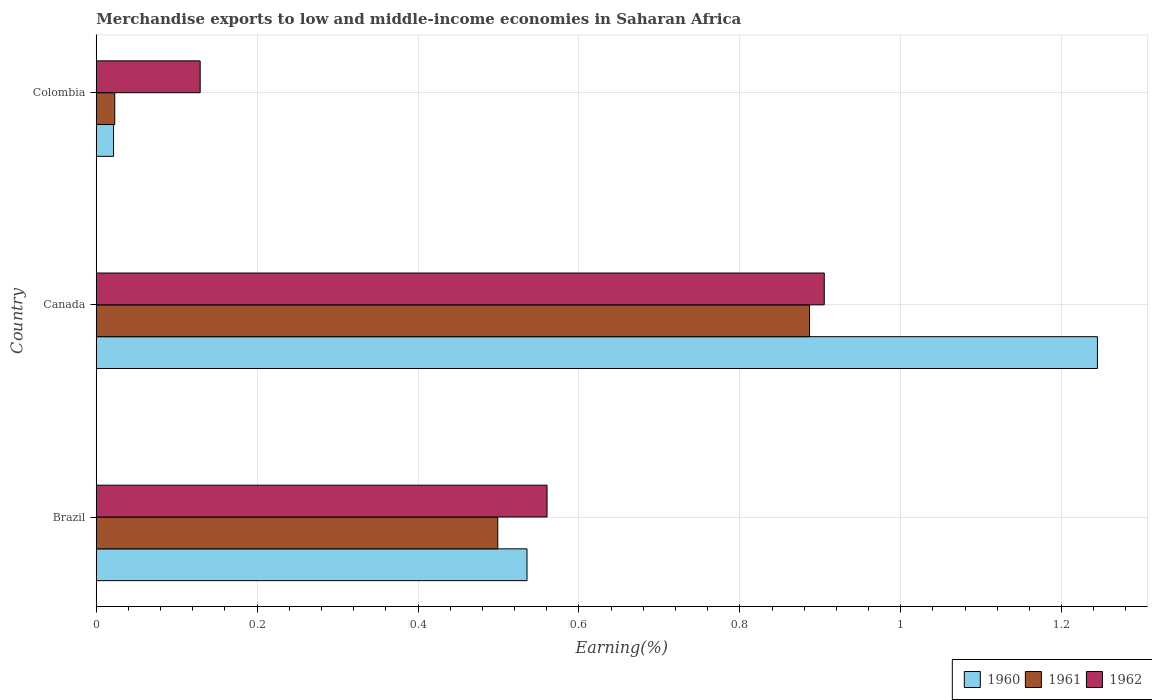How many different coloured bars are there?
Offer a very short reply. 3. Are the number of bars per tick equal to the number of legend labels?
Offer a very short reply. Yes. How many bars are there on the 3rd tick from the top?
Your answer should be compact. 3. What is the label of the 1st group of bars from the top?
Give a very brief answer. Colombia. In how many cases, is the number of bars for a given country not equal to the number of legend labels?
Your response must be concise. 0. What is the percentage of amount earned from merchandise exports in 1960 in Canada?
Ensure brevity in your answer.  1.24. Across all countries, what is the maximum percentage of amount earned from merchandise exports in 1962?
Provide a succinct answer. 0.9. Across all countries, what is the minimum percentage of amount earned from merchandise exports in 1961?
Offer a very short reply. 0.02. In which country was the percentage of amount earned from merchandise exports in 1961 maximum?
Provide a short and direct response. Canada. What is the total percentage of amount earned from merchandise exports in 1961 in the graph?
Provide a succinct answer. 1.41. What is the difference between the percentage of amount earned from merchandise exports in 1961 in Brazil and that in Colombia?
Your answer should be very brief. 0.48. What is the difference between the percentage of amount earned from merchandise exports in 1960 in Canada and the percentage of amount earned from merchandise exports in 1961 in Colombia?
Offer a terse response. 1.22. What is the average percentage of amount earned from merchandise exports in 1960 per country?
Offer a terse response. 0.6. What is the difference between the percentage of amount earned from merchandise exports in 1962 and percentage of amount earned from merchandise exports in 1960 in Colombia?
Make the answer very short. 0.11. What is the ratio of the percentage of amount earned from merchandise exports in 1961 in Brazil to that in Colombia?
Offer a terse response. 21.72. Is the difference between the percentage of amount earned from merchandise exports in 1962 in Canada and Colombia greater than the difference between the percentage of amount earned from merchandise exports in 1960 in Canada and Colombia?
Offer a very short reply. No. What is the difference between the highest and the second highest percentage of amount earned from merchandise exports in 1961?
Your response must be concise. 0.39. What is the difference between the highest and the lowest percentage of amount earned from merchandise exports in 1962?
Give a very brief answer. 0.78. How many bars are there?
Provide a short and direct response. 9. How many countries are there in the graph?
Your answer should be very brief. 3. What is the difference between two consecutive major ticks on the X-axis?
Provide a succinct answer. 0.2. Are the values on the major ticks of X-axis written in scientific E-notation?
Offer a terse response. No. Does the graph contain any zero values?
Ensure brevity in your answer.  No. Does the graph contain grids?
Your answer should be compact. Yes. Where does the legend appear in the graph?
Your answer should be very brief. Bottom right. How are the legend labels stacked?
Offer a terse response. Horizontal. What is the title of the graph?
Offer a very short reply. Merchandise exports to low and middle-income economies in Saharan Africa. Does "2011" appear as one of the legend labels in the graph?
Your answer should be very brief. No. What is the label or title of the X-axis?
Your answer should be compact. Earning(%). What is the label or title of the Y-axis?
Keep it short and to the point. Country. What is the Earning(%) in 1960 in Brazil?
Make the answer very short. 0.54. What is the Earning(%) in 1961 in Brazil?
Your answer should be compact. 0.5. What is the Earning(%) of 1962 in Brazil?
Offer a terse response. 0.56. What is the Earning(%) in 1960 in Canada?
Provide a short and direct response. 1.24. What is the Earning(%) in 1961 in Canada?
Your answer should be very brief. 0.89. What is the Earning(%) of 1962 in Canada?
Provide a succinct answer. 0.9. What is the Earning(%) in 1960 in Colombia?
Your answer should be compact. 0.02. What is the Earning(%) of 1961 in Colombia?
Make the answer very short. 0.02. What is the Earning(%) in 1962 in Colombia?
Give a very brief answer. 0.13. Across all countries, what is the maximum Earning(%) in 1960?
Keep it short and to the point. 1.24. Across all countries, what is the maximum Earning(%) in 1961?
Your response must be concise. 0.89. Across all countries, what is the maximum Earning(%) of 1962?
Offer a very short reply. 0.9. Across all countries, what is the minimum Earning(%) in 1960?
Keep it short and to the point. 0.02. Across all countries, what is the minimum Earning(%) in 1961?
Ensure brevity in your answer.  0.02. Across all countries, what is the minimum Earning(%) of 1962?
Keep it short and to the point. 0.13. What is the total Earning(%) of 1960 in the graph?
Make the answer very short. 1.8. What is the total Earning(%) of 1961 in the graph?
Offer a terse response. 1.41. What is the total Earning(%) in 1962 in the graph?
Your answer should be very brief. 1.59. What is the difference between the Earning(%) in 1960 in Brazil and that in Canada?
Provide a short and direct response. -0.71. What is the difference between the Earning(%) of 1961 in Brazil and that in Canada?
Make the answer very short. -0.39. What is the difference between the Earning(%) of 1962 in Brazil and that in Canada?
Your answer should be compact. -0.34. What is the difference between the Earning(%) of 1960 in Brazil and that in Colombia?
Your answer should be very brief. 0.51. What is the difference between the Earning(%) of 1961 in Brazil and that in Colombia?
Make the answer very short. 0.48. What is the difference between the Earning(%) of 1962 in Brazil and that in Colombia?
Make the answer very short. 0.43. What is the difference between the Earning(%) of 1960 in Canada and that in Colombia?
Provide a succinct answer. 1.22. What is the difference between the Earning(%) in 1961 in Canada and that in Colombia?
Your response must be concise. 0.86. What is the difference between the Earning(%) in 1962 in Canada and that in Colombia?
Make the answer very short. 0.78. What is the difference between the Earning(%) in 1960 in Brazil and the Earning(%) in 1961 in Canada?
Offer a terse response. -0.35. What is the difference between the Earning(%) in 1960 in Brazil and the Earning(%) in 1962 in Canada?
Offer a very short reply. -0.37. What is the difference between the Earning(%) of 1961 in Brazil and the Earning(%) of 1962 in Canada?
Keep it short and to the point. -0.41. What is the difference between the Earning(%) of 1960 in Brazil and the Earning(%) of 1961 in Colombia?
Keep it short and to the point. 0.51. What is the difference between the Earning(%) in 1960 in Brazil and the Earning(%) in 1962 in Colombia?
Make the answer very short. 0.41. What is the difference between the Earning(%) in 1961 in Brazil and the Earning(%) in 1962 in Colombia?
Ensure brevity in your answer.  0.37. What is the difference between the Earning(%) of 1960 in Canada and the Earning(%) of 1961 in Colombia?
Provide a short and direct response. 1.22. What is the difference between the Earning(%) of 1960 in Canada and the Earning(%) of 1962 in Colombia?
Offer a terse response. 1.12. What is the difference between the Earning(%) in 1961 in Canada and the Earning(%) in 1962 in Colombia?
Give a very brief answer. 0.76. What is the average Earning(%) of 1960 per country?
Give a very brief answer. 0.6. What is the average Earning(%) of 1961 per country?
Give a very brief answer. 0.47. What is the average Earning(%) of 1962 per country?
Your answer should be very brief. 0.53. What is the difference between the Earning(%) in 1960 and Earning(%) in 1961 in Brazil?
Offer a terse response. 0.04. What is the difference between the Earning(%) of 1960 and Earning(%) of 1962 in Brazil?
Your answer should be very brief. -0.02. What is the difference between the Earning(%) of 1961 and Earning(%) of 1962 in Brazil?
Keep it short and to the point. -0.06. What is the difference between the Earning(%) of 1960 and Earning(%) of 1961 in Canada?
Keep it short and to the point. 0.36. What is the difference between the Earning(%) of 1960 and Earning(%) of 1962 in Canada?
Ensure brevity in your answer.  0.34. What is the difference between the Earning(%) of 1961 and Earning(%) of 1962 in Canada?
Provide a succinct answer. -0.02. What is the difference between the Earning(%) of 1960 and Earning(%) of 1961 in Colombia?
Ensure brevity in your answer.  -0. What is the difference between the Earning(%) of 1960 and Earning(%) of 1962 in Colombia?
Give a very brief answer. -0.11. What is the difference between the Earning(%) of 1961 and Earning(%) of 1962 in Colombia?
Your answer should be very brief. -0.11. What is the ratio of the Earning(%) in 1960 in Brazil to that in Canada?
Your answer should be compact. 0.43. What is the ratio of the Earning(%) in 1961 in Brazil to that in Canada?
Your answer should be very brief. 0.56. What is the ratio of the Earning(%) of 1962 in Brazil to that in Canada?
Offer a very short reply. 0.62. What is the ratio of the Earning(%) in 1960 in Brazil to that in Colombia?
Ensure brevity in your answer.  24.92. What is the ratio of the Earning(%) of 1961 in Brazil to that in Colombia?
Provide a short and direct response. 21.72. What is the ratio of the Earning(%) of 1962 in Brazil to that in Colombia?
Ensure brevity in your answer.  4.34. What is the ratio of the Earning(%) in 1960 in Canada to that in Colombia?
Keep it short and to the point. 57.92. What is the ratio of the Earning(%) in 1961 in Canada to that in Colombia?
Your answer should be very brief. 38.58. What is the ratio of the Earning(%) of 1962 in Canada to that in Colombia?
Provide a succinct answer. 7.01. What is the difference between the highest and the second highest Earning(%) in 1960?
Give a very brief answer. 0.71. What is the difference between the highest and the second highest Earning(%) of 1961?
Ensure brevity in your answer.  0.39. What is the difference between the highest and the second highest Earning(%) of 1962?
Your answer should be very brief. 0.34. What is the difference between the highest and the lowest Earning(%) in 1960?
Your response must be concise. 1.22. What is the difference between the highest and the lowest Earning(%) in 1961?
Your response must be concise. 0.86. What is the difference between the highest and the lowest Earning(%) in 1962?
Your response must be concise. 0.78. 